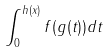Convert formula to latex. <formula><loc_0><loc_0><loc_500><loc_500>\int _ { 0 } ^ { h ( x ) } f ( g ( t ) ) d t</formula> 